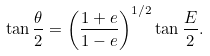<formula> <loc_0><loc_0><loc_500><loc_500>\tan \frac { \theta } { 2 } = \left ( \frac { 1 + e } { 1 - e } \right ) ^ { 1 / 2 } \tan \frac { E } { 2 } .</formula> 